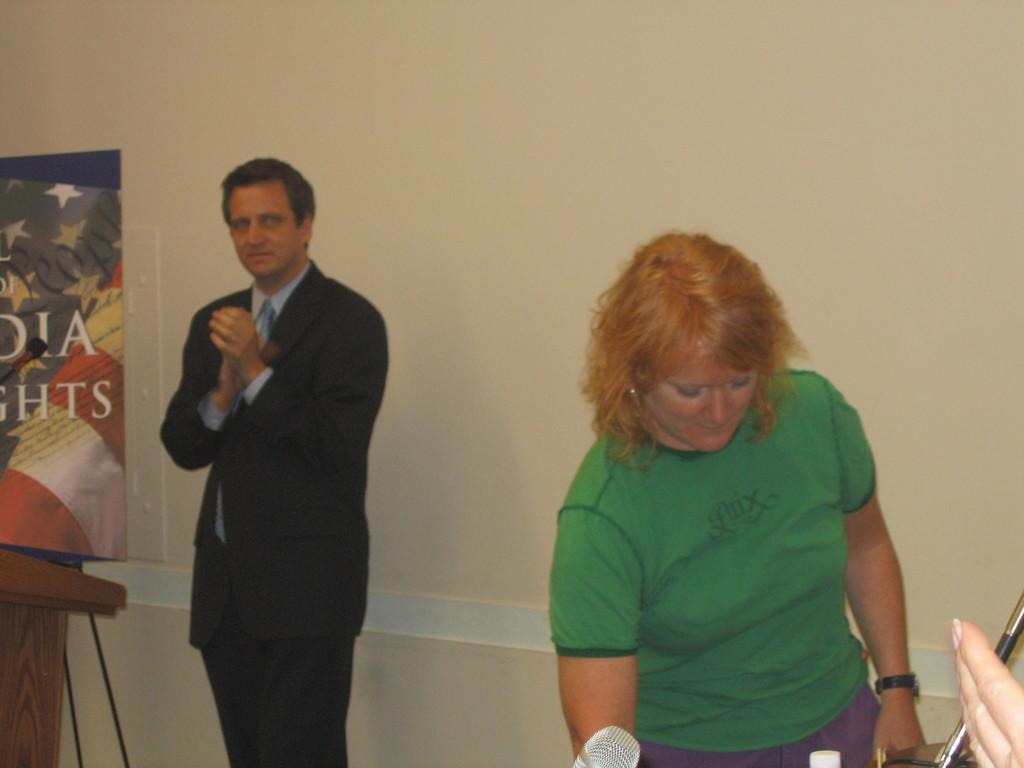Could you give a brief overview of what you see in this image? The picture is clicked inside a room. In left there is a painting. A man is standing is wearing suit. He is clapping. In the right a lady wearing green t-shirt is standing. Another hand is visible here. In the foreground there is mic. In the background there is wall. 